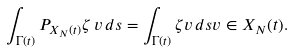<formula> <loc_0><loc_0><loc_500><loc_500>\int _ { \Gamma ( t ) } P _ { X _ { N } ( t ) } \zeta \, v \, d s = \int _ { \Gamma ( t ) } \zeta v \, d s v \in X _ { N } ( t ) .</formula> 